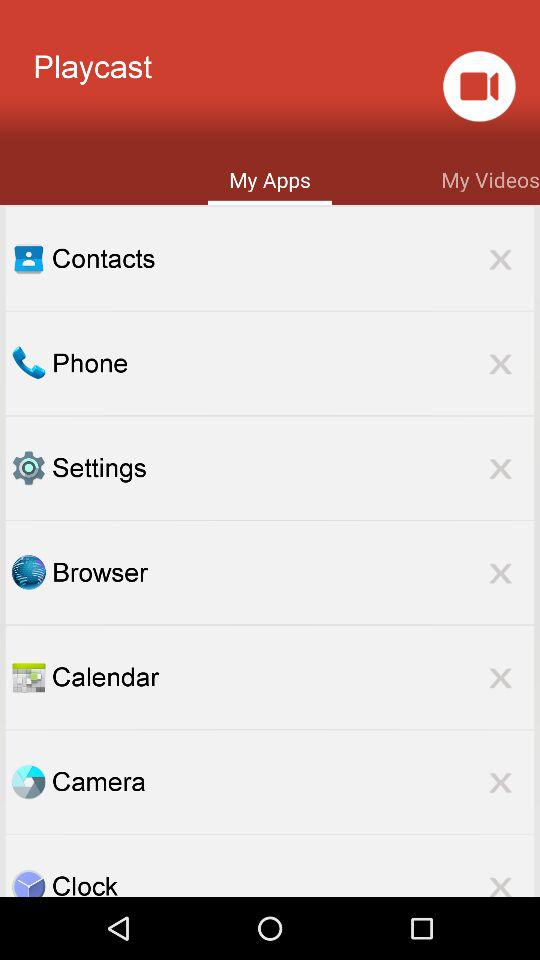Which tab is selected? The selected tab is "My Apps". 